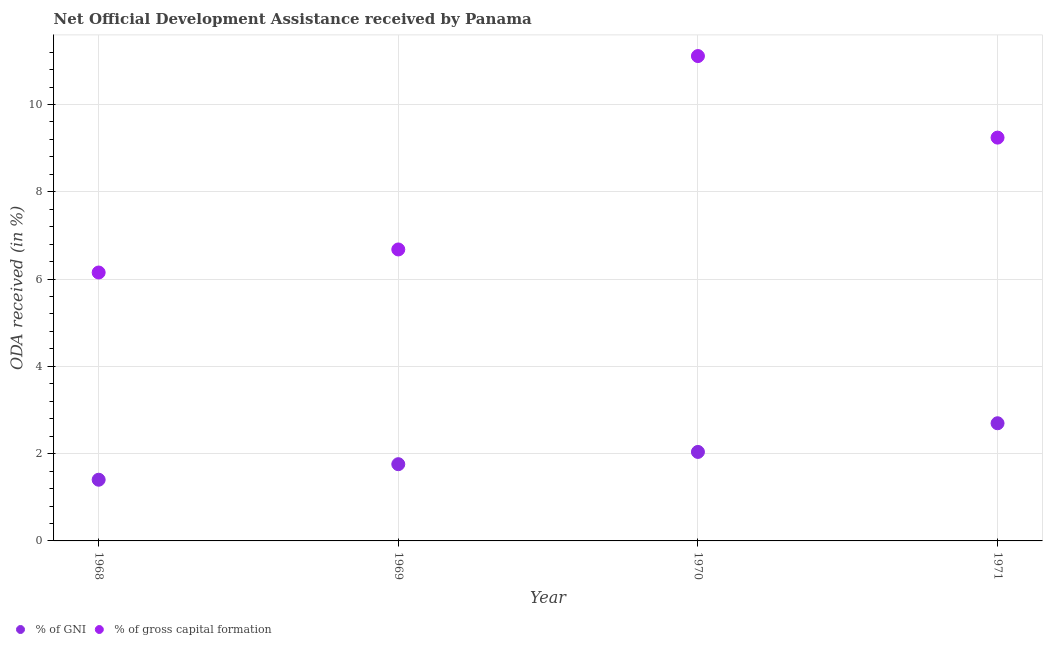How many different coloured dotlines are there?
Provide a short and direct response. 2. What is the oda received as percentage of gni in 1969?
Provide a succinct answer. 1.76. Across all years, what is the maximum oda received as percentage of gross capital formation?
Ensure brevity in your answer.  11.11. Across all years, what is the minimum oda received as percentage of gni?
Offer a very short reply. 1.4. In which year was the oda received as percentage of gni maximum?
Keep it short and to the point. 1971. In which year was the oda received as percentage of gross capital formation minimum?
Provide a succinct answer. 1968. What is the total oda received as percentage of gni in the graph?
Keep it short and to the point. 7.9. What is the difference between the oda received as percentage of gross capital formation in 1968 and that in 1971?
Offer a very short reply. -3.09. What is the difference between the oda received as percentage of gni in 1968 and the oda received as percentage of gross capital formation in 1970?
Provide a short and direct response. -9.71. What is the average oda received as percentage of gni per year?
Your answer should be very brief. 1.97. In the year 1968, what is the difference between the oda received as percentage of gross capital formation and oda received as percentage of gni?
Your answer should be very brief. 4.75. What is the ratio of the oda received as percentage of gross capital formation in 1970 to that in 1971?
Provide a short and direct response. 1.2. What is the difference between the highest and the second highest oda received as percentage of gni?
Provide a short and direct response. 0.66. What is the difference between the highest and the lowest oda received as percentage of gni?
Your response must be concise. 1.29. Is the sum of the oda received as percentage of gni in 1968 and 1969 greater than the maximum oda received as percentage of gross capital formation across all years?
Your answer should be very brief. No. Does the oda received as percentage of gross capital formation monotonically increase over the years?
Your answer should be very brief. No. Is the oda received as percentage of gni strictly less than the oda received as percentage of gross capital formation over the years?
Make the answer very short. Yes. How many dotlines are there?
Your answer should be very brief. 2. What is the difference between two consecutive major ticks on the Y-axis?
Offer a very short reply. 2. Does the graph contain any zero values?
Your answer should be very brief. No. Does the graph contain grids?
Provide a succinct answer. Yes. How many legend labels are there?
Keep it short and to the point. 2. What is the title of the graph?
Provide a succinct answer. Net Official Development Assistance received by Panama. What is the label or title of the Y-axis?
Your answer should be very brief. ODA received (in %). What is the ODA received (in %) in % of GNI in 1968?
Give a very brief answer. 1.4. What is the ODA received (in %) of % of gross capital formation in 1968?
Offer a terse response. 6.15. What is the ODA received (in %) of % of GNI in 1969?
Give a very brief answer. 1.76. What is the ODA received (in %) of % of gross capital formation in 1969?
Your answer should be compact. 6.68. What is the ODA received (in %) of % of GNI in 1970?
Make the answer very short. 2.04. What is the ODA received (in %) of % of gross capital formation in 1970?
Provide a succinct answer. 11.11. What is the ODA received (in %) in % of GNI in 1971?
Your answer should be compact. 2.7. What is the ODA received (in %) in % of gross capital formation in 1971?
Ensure brevity in your answer.  9.24. Across all years, what is the maximum ODA received (in %) of % of GNI?
Make the answer very short. 2.7. Across all years, what is the maximum ODA received (in %) in % of gross capital formation?
Your response must be concise. 11.11. Across all years, what is the minimum ODA received (in %) of % of GNI?
Provide a succinct answer. 1.4. Across all years, what is the minimum ODA received (in %) in % of gross capital formation?
Your answer should be compact. 6.15. What is the total ODA received (in %) of % of GNI in the graph?
Give a very brief answer. 7.9. What is the total ODA received (in %) of % of gross capital formation in the graph?
Your answer should be compact. 33.18. What is the difference between the ODA received (in %) of % of GNI in 1968 and that in 1969?
Offer a terse response. -0.36. What is the difference between the ODA received (in %) in % of gross capital formation in 1968 and that in 1969?
Ensure brevity in your answer.  -0.53. What is the difference between the ODA received (in %) of % of GNI in 1968 and that in 1970?
Offer a terse response. -0.64. What is the difference between the ODA received (in %) in % of gross capital formation in 1968 and that in 1970?
Provide a succinct answer. -4.96. What is the difference between the ODA received (in %) of % of GNI in 1968 and that in 1971?
Keep it short and to the point. -1.29. What is the difference between the ODA received (in %) of % of gross capital formation in 1968 and that in 1971?
Ensure brevity in your answer.  -3.09. What is the difference between the ODA received (in %) in % of GNI in 1969 and that in 1970?
Offer a very short reply. -0.28. What is the difference between the ODA received (in %) in % of gross capital formation in 1969 and that in 1970?
Offer a terse response. -4.43. What is the difference between the ODA received (in %) in % of GNI in 1969 and that in 1971?
Your response must be concise. -0.94. What is the difference between the ODA received (in %) of % of gross capital formation in 1969 and that in 1971?
Your response must be concise. -2.56. What is the difference between the ODA received (in %) of % of GNI in 1970 and that in 1971?
Give a very brief answer. -0.66. What is the difference between the ODA received (in %) in % of gross capital formation in 1970 and that in 1971?
Your answer should be very brief. 1.87. What is the difference between the ODA received (in %) in % of GNI in 1968 and the ODA received (in %) in % of gross capital formation in 1969?
Provide a succinct answer. -5.28. What is the difference between the ODA received (in %) in % of GNI in 1968 and the ODA received (in %) in % of gross capital formation in 1970?
Offer a terse response. -9.71. What is the difference between the ODA received (in %) in % of GNI in 1968 and the ODA received (in %) in % of gross capital formation in 1971?
Keep it short and to the point. -7.84. What is the difference between the ODA received (in %) in % of GNI in 1969 and the ODA received (in %) in % of gross capital formation in 1970?
Give a very brief answer. -9.35. What is the difference between the ODA received (in %) in % of GNI in 1969 and the ODA received (in %) in % of gross capital formation in 1971?
Offer a terse response. -7.48. What is the difference between the ODA received (in %) in % of GNI in 1970 and the ODA received (in %) in % of gross capital formation in 1971?
Give a very brief answer. -7.2. What is the average ODA received (in %) in % of GNI per year?
Keep it short and to the point. 1.97. What is the average ODA received (in %) of % of gross capital formation per year?
Make the answer very short. 8.3. In the year 1968, what is the difference between the ODA received (in %) in % of GNI and ODA received (in %) in % of gross capital formation?
Keep it short and to the point. -4.75. In the year 1969, what is the difference between the ODA received (in %) in % of GNI and ODA received (in %) in % of gross capital formation?
Offer a terse response. -4.92. In the year 1970, what is the difference between the ODA received (in %) of % of GNI and ODA received (in %) of % of gross capital formation?
Keep it short and to the point. -9.07. In the year 1971, what is the difference between the ODA received (in %) of % of GNI and ODA received (in %) of % of gross capital formation?
Offer a very short reply. -6.55. What is the ratio of the ODA received (in %) in % of GNI in 1968 to that in 1969?
Provide a short and direct response. 0.8. What is the ratio of the ODA received (in %) of % of gross capital formation in 1968 to that in 1969?
Your answer should be very brief. 0.92. What is the ratio of the ODA received (in %) in % of GNI in 1968 to that in 1970?
Offer a terse response. 0.69. What is the ratio of the ODA received (in %) of % of gross capital formation in 1968 to that in 1970?
Offer a terse response. 0.55. What is the ratio of the ODA received (in %) in % of GNI in 1968 to that in 1971?
Ensure brevity in your answer.  0.52. What is the ratio of the ODA received (in %) in % of gross capital formation in 1968 to that in 1971?
Make the answer very short. 0.67. What is the ratio of the ODA received (in %) of % of GNI in 1969 to that in 1970?
Make the answer very short. 0.86. What is the ratio of the ODA received (in %) in % of gross capital formation in 1969 to that in 1970?
Your response must be concise. 0.6. What is the ratio of the ODA received (in %) of % of GNI in 1969 to that in 1971?
Offer a very short reply. 0.65. What is the ratio of the ODA received (in %) of % of gross capital formation in 1969 to that in 1971?
Provide a short and direct response. 0.72. What is the ratio of the ODA received (in %) in % of GNI in 1970 to that in 1971?
Offer a very short reply. 0.76. What is the ratio of the ODA received (in %) of % of gross capital formation in 1970 to that in 1971?
Your response must be concise. 1.2. What is the difference between the highest and the second highest ODA received (in %) in % of GNI?
Your response must be concise. 0.66. What is the difference between the highest and the second highest ODA received (in %) of % of gross capital formation?
Provide a short and direct response. 1.87. What is the difference between the highest and the lowest ODA received (in %) of % of GNI?
Your answer should be very brief. 1.29. What is the difference between the highest and the lowest ODA received (in %) in % of gross capital formation?
Offer a very short reply. 4.96. 